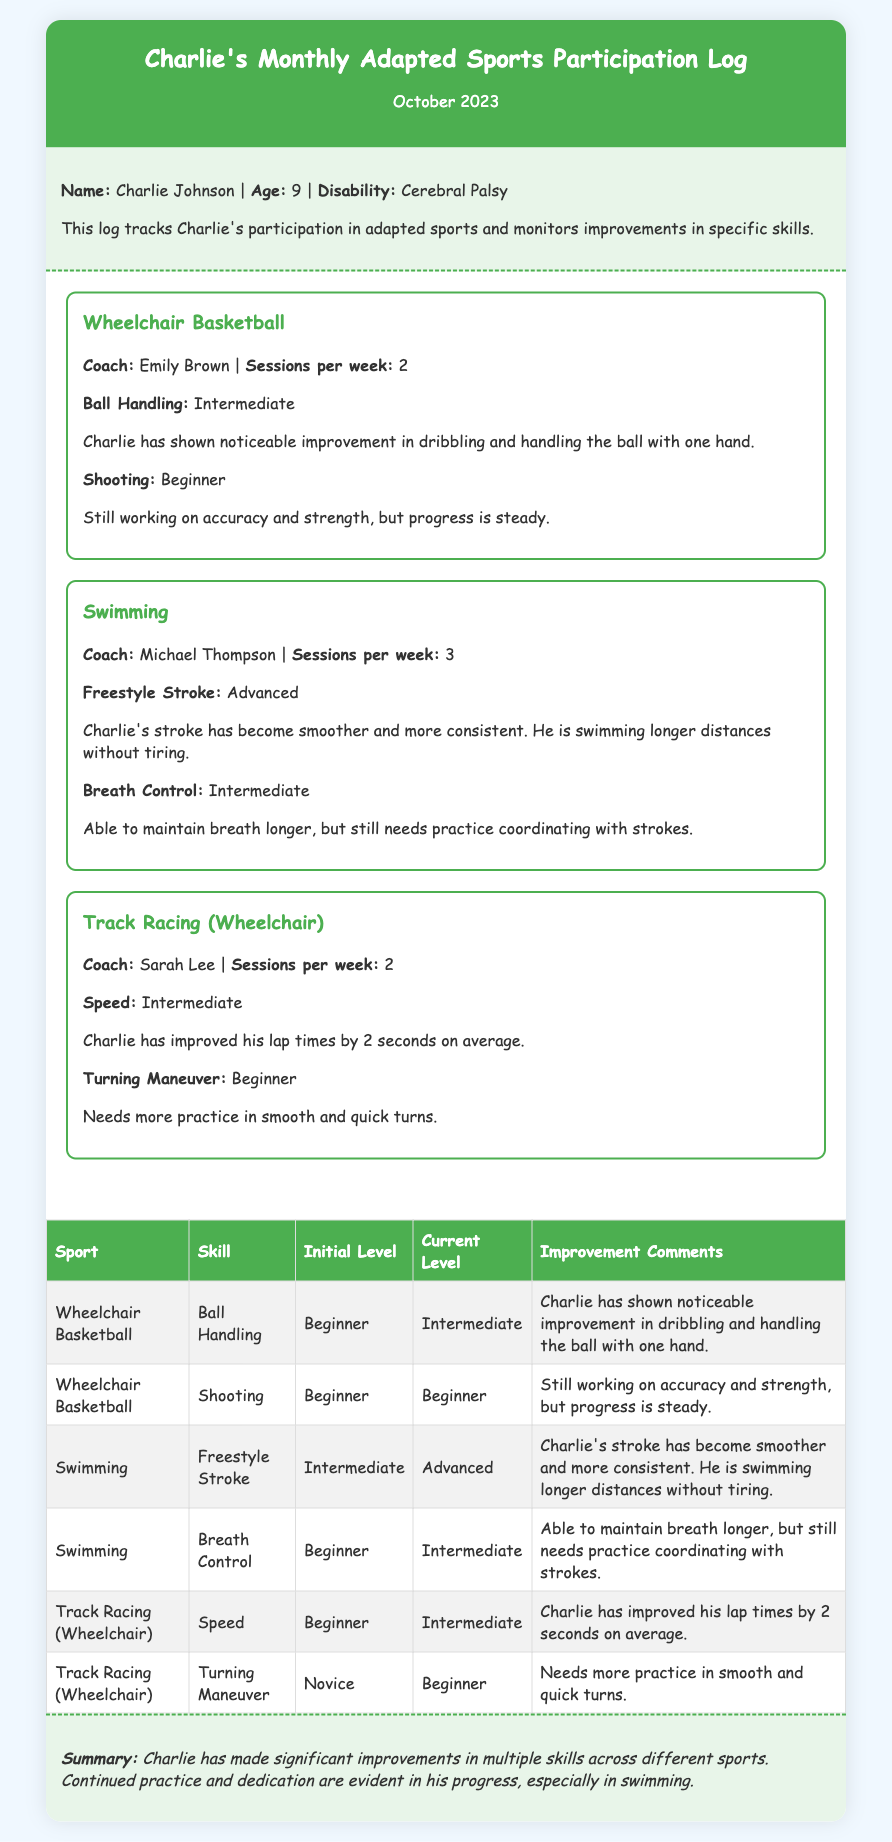What is Charlie's age? Charlie's age is specified in the document, which states he is 9 years old.
Answer: 9 Who is Charlie's coach for Swimming? The document lists Michael Thompson as the coach for Swimming.
Answer: Michael Thompson How many sessions per week does Charlie have for Track Racing? The document indicates that Charlie has 2 sessions per week for Track Racing.
Answer: 2 What is Charlie's current skill level in Ball Handling? The document states that Charlie's current skill level in Ball Handling is Intermediate.
Answer: Intermediate How much has Charlie improved his lap times in Track Racing? The document mentions that Charlie has improved his lap times by 2 seconds on average.
Answer: 2 seconds Which sport shows Charlie's skill as Advanced? The document specifies that his skill in Freestyle Stroke for Swimming is rated as Advanced.
Answer: Freestyle Stroke What improvement does Charlie need in Turning Maneuver for Track Racing? The document says Charlie needs more practice in smooth and quick turns for Turning Maneuver.
Answer: Practice in smooth and quick turns What sport does Charlie participate in with sessions 3 times a week? The document indicates that Charlie participates in Swimming with 3 sessions per week.
Answer: Swimming What summary statement is made about Charlie's improvements? The document provides a summary stating that Charlie has made significant improvements in multiple skills across different sports.
Answer: Significant improvements in multiple skills 